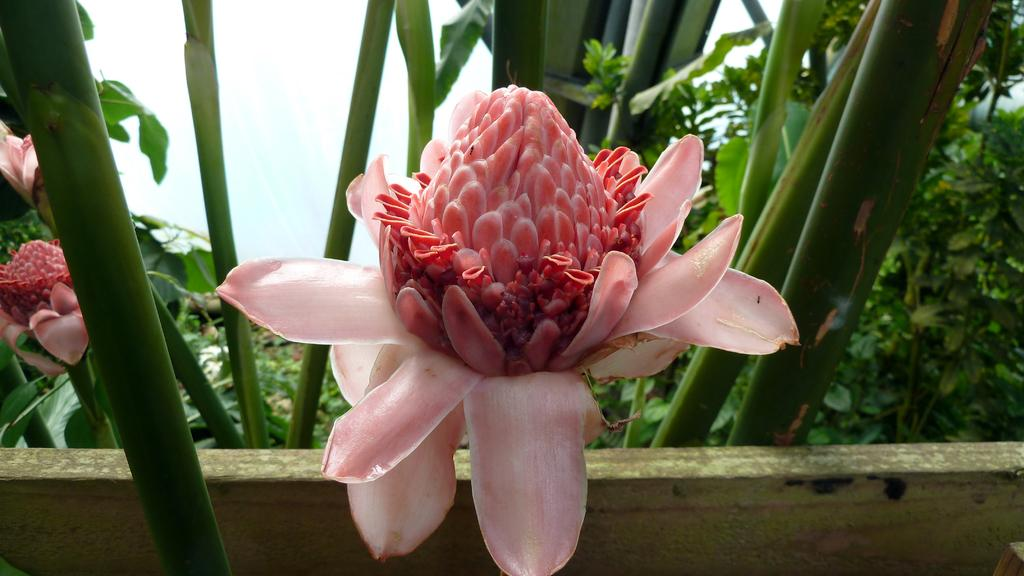What type of living organisms can be seen in the image? Plants and flowers are visible in the image. Can you describe the flowers in the image? The flowers in the image are part of the plants and add color to the scene. What type of tree can be seen in the image? There is no tree present in the image; it only features plants and flowers. What is the relation between the plants and the flowers in the image? The flowers are part of the plants, as they grow on the stems and add color to the plants. 